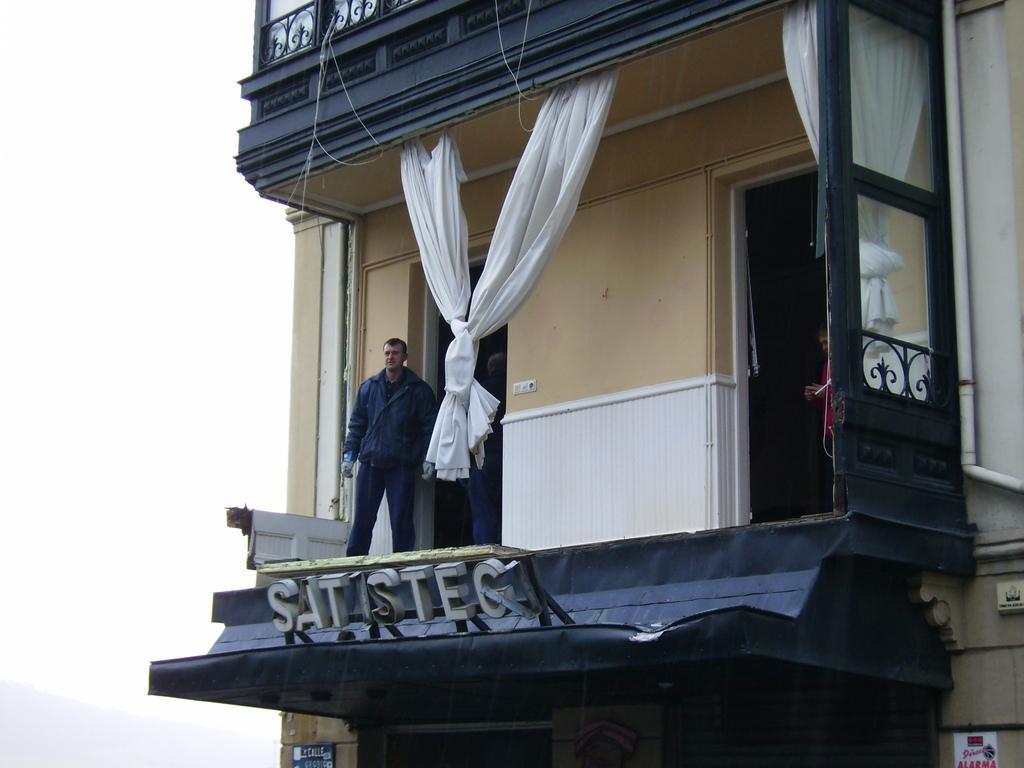Can you describe this image briefly? In this image there is a building and we can see people standing on the building. There are curtains and doors. At the bottom there is a board. In the background there there is a hill and sky. 